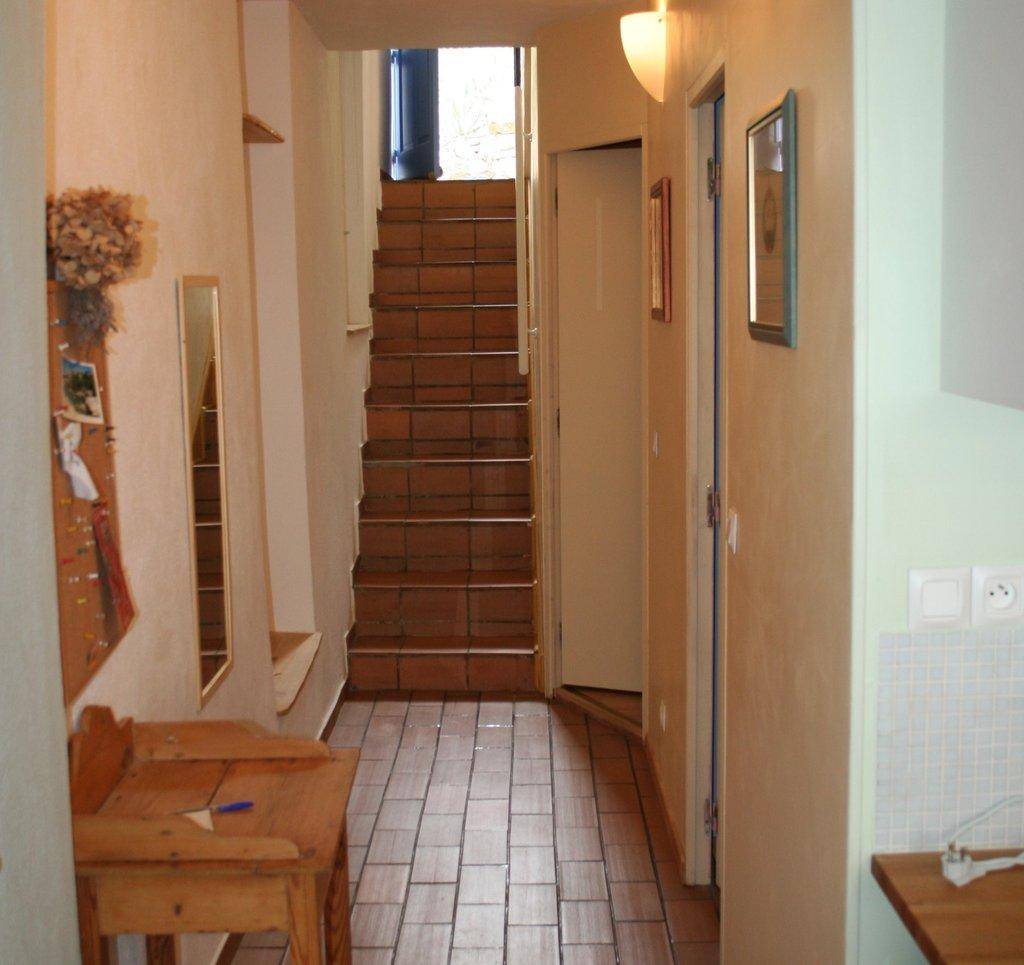What type of structure can be seen in the image? There are stairs in the image. What can be used for personal grooming or checking appearance in the image? There is a mirror in the image. What is hanging on the wall in the image? There are photo frames on the wall in the image. What piece of furniture is present in the image? There is a table in the image. What can be used for entering or exiting a room in the image? There are doors in the image. Can you see a cow grazing on the stairs in the image? No, there is no cow present in the image. What type of bean is growing on the table in the image? There are no beans present in the image; it features stairs, a mirror, photo frames, a table, and doors. 